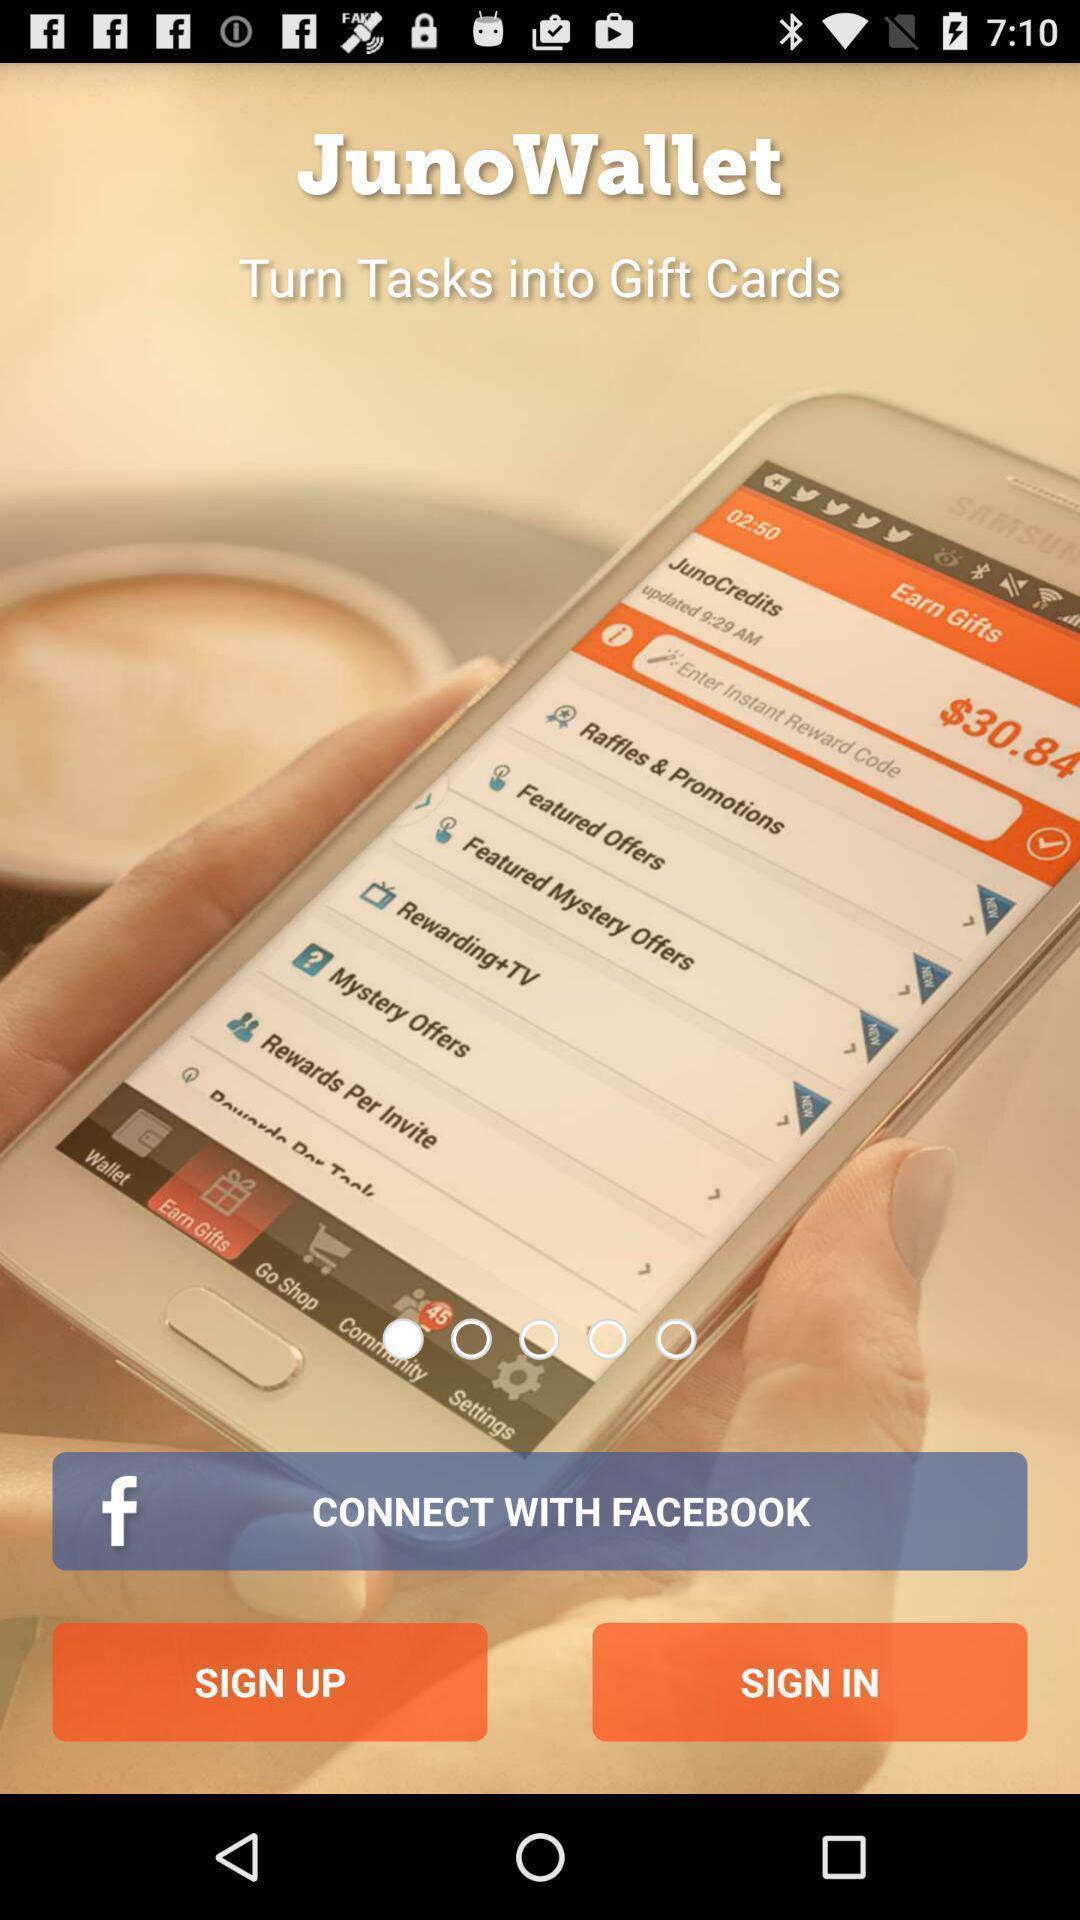Provide a detailed account of this screenshot. Starting page for a wallet app. 